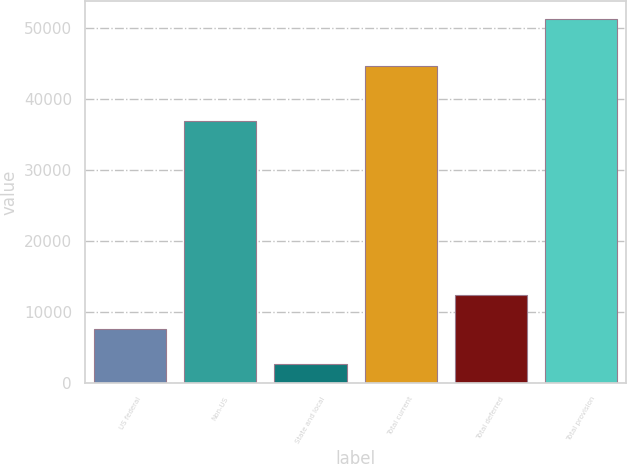Convert chart to OTSL. <chart><loc_0><loc_0><loc_500><loc_500><bar_chart><fcel>US federal<fcel>Non-US<fcel>State and local<fcel>Total current<fcel>Total deferred<fcel>Total provision<nl><fcel>7504.7<fcel>36897<fcel>2647<fcel>44694<fcel>12362.4<fcel>51224<nl></chart> 